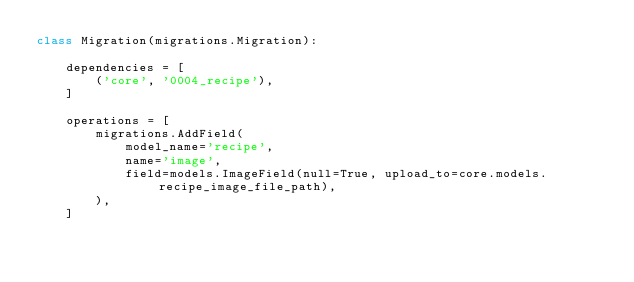<code> <loc_0><loc_0><loc_500><loc_500><_Python_>class Migration(migrations.Migration):

    dependencies = [
        ('core', '0004_recipe'),
    ]

    operations = [
        migrations.AddField(
            model_name='recipe',
            name='image',
            field=models.ImageField(null=True, upload_to=core.models.recipe_image_file_path),
        ),
    ]
</code> 